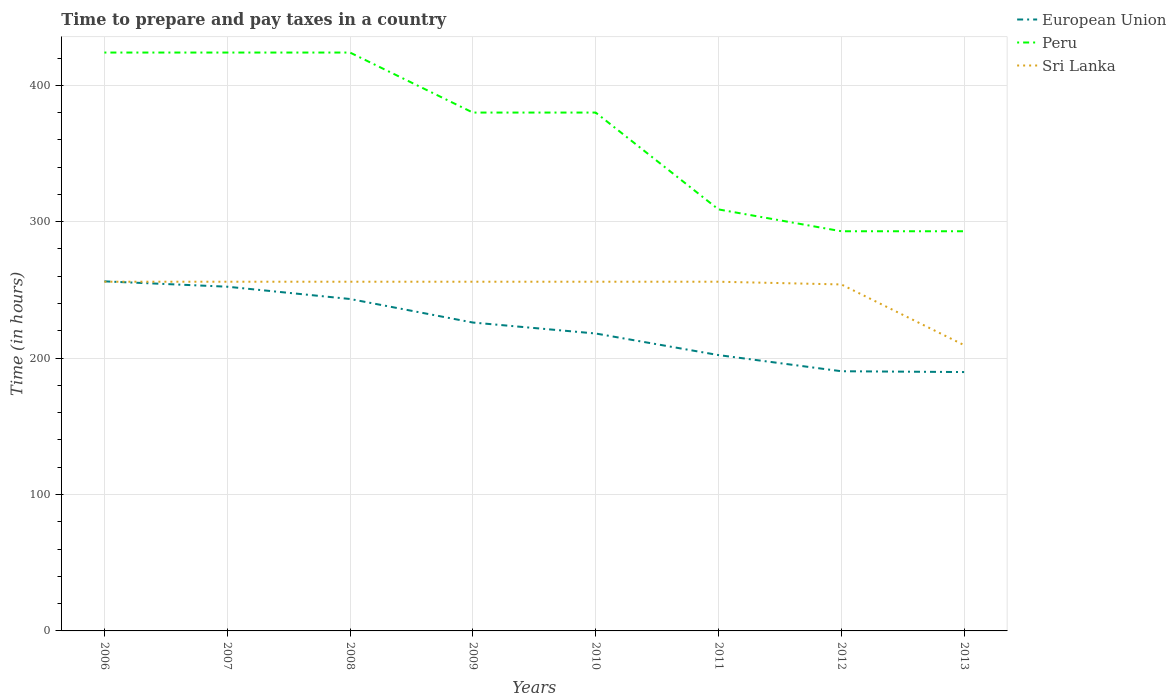How many different coloured lines are there?
Offer a very short reply. 3. Does the line corresponding to Sri Lanka intersect with the line corresponding to Peru?
Give a very brief answer. No. Across all years, what is the maximum number of hours required to prepare and pay taxes in Sri Lanka?
Ensure brevity in your answer.  209.5. What is the difference between the highest and the second highest number of hours required to prepare and pay taxes in Sri Lanka?
Offer a terse response. 46.5. What is the difference between the highest and the lowest number of hours required to prepare and pay taxes in Sri Lanka?
Ensure brevity in your answer.  7. Is the number of hours required to prepare and pay taxes in European Union strictly greater than the number of hours required to prepare and pay taxes in Peru over the years?
Offer a terse response. Yes. Does the graph contain any zero values?
Your answer should be compact. No. How many legend labels are there?
Ensure brevity in your answer.  3. How are the legend labels stacked?
Make the answer very short. Vertical. What is the title of the graph?
Offer a terse response. Time to prepare and pay taxes in a country. Does "Cabo Verde" appear as one of the legend labels in the graph?
Your response must be concise. No. What is the label or title of the Y-axis?
Provide a succinct answer. Time (in hours). What is the Time (in hours) of European Union in 2006?
Provide a succinct answer. 256.27. What is the Time (in hours) of Peru in 2006?
Your answer should be very brief. 424. What is the Time (in hours) of Sri Lanka in 2006?
Provide a succinct answer. 256. What is the Time (in hours) of European Union in 2007?
Keep it short and to the point. 252.35. What is the Time (in hours) of Peru in 2007?
Make the answer very short. 424. What is the Time (in hours) in Sri Lanka in 2007?
Ensure brevity in your answer.  256. What is the Time (in hours) of European Union in 2008?
Keep it short and to the point. 243.33. What is the Time (in hours) of Peru in 2008?
Provide a short and direct response. 424. What is the Time (in hours) of Sri Lanka in 2008?
Ensure brevity in your answer.  256. What is the Time (in hours) of European Union in 2009?
Give a very brief answer. 226.07. What is the Time (in hours) in Peru in 2009?
Provide a short and direct response. 380. What is the Time (in hours) of Sri Lanka in 2009?
Offer a very short reply. 256. What is the Time (in hours) of European Union in 2010?
Keep it short and to the point. 218.04. What is the Time (in hours) in Peru in 2010?
Provide a short and direct response. 380. What is the Time (in hours) in Sri Lanka in 2010?
Provide a succinct answer. 256. What is the Time (in hours) in European Union in 2011?
Provide a succinct answer. 202.21. What is the Time (in hours) in Peru in 2011?
Provide a short and direct response. 309. What is the Time (in hours) of Sri Lanka in 2011?
Keep it short and to the point. 256. What is the Time (in hours) of European Union in 2012?
Ensure brevity in your answer.  190.38. What is the Time (in hours) in Peru in 2012?
Your answer should be compact. 293. What is the Time (in hours) in Sri Lanka in 2012?
Provide a short and direct response. 254. What is the Time (in hours) in European Union in 2013?
Ensure brevity in your answer.  189.77. What is the Time (in hours) of Peru in 2013?
Provide a short and direct response. 293. What is the Time (in hours) in Sri Lanka in 2013?
Your response must be concise. 209.5. Across all years, what is the maximum Time (in hours) in European Union?
Keep it short and to the point. 256.27. Across all years, what is the maximum Time (in hours) in Peru?
Offer a terse response. 424. Across all years, what is the maximum Time (in hours) in Sri Lanka?
Your answer should be very brief. 256. Across all years, what is the minimum Time (in hours) in European Union?
Offer a very short reply. 189.77. Across all years, what is the minimum Time (in hours) of Peru?
Keep it short and to the point. 293. Across all years, what is the minimum Time (in hours) of Sri Lanka?
Ensure brevity in your answer.  209.5. What is the total Time (in hours) in European Union in the graph?
Provide a short and direct response. 1778.42. What is the total Time (in hours) in Peru in the graph?
Your answer should be very brief. 2927. What is the total Time (in hours) of Sri Lanka in the graph?
Offer a terse response. 1999.5. What is the difference between the Time (in hours) in European Union in 2006 and that in 2007?
Provide a succinct answer. 3.92. What is the difference between the Time (in hours) of Sri Lanka in 2006 and that in 2007?
Give a very brief answer. 0. What is the difference between the Time (in hours) in European Union in 2006 and that in 2008?
Keep it short and to the point. 12.94. What is the difference between the Time (in hours) of Peru in 2006 and that in 2008?
Your answer should be compact. 0. What is the difference between the Time (in hours) of European Union in 2006 and that in 2009?
Your response must be concise. 30.2. What is the difference between the Time (in hours) in European Union in 2006 and that in 2010?
Make the answer very short. 38.23. What is the difference between the Time (in hours) of Peru in 2006 and that in 2010?
Give a very brief answer. 44. What is the difference between the Time (in hours) of European Union in 2006 and that in 2011?
Your answer should be very brief. 54.05. What is the difference between the Time (in hours) in Peru in 2006 and that in 2011?
Your answer should be compact. 115. What is the difference between the Time (in hours) of Sri Lanka in 2006 and that in 2011?
Your response must be concise. 0. What is the difference between the Time (in hours) in European Union in 2006 and that in 2012?
Your answer should be compact. 65.89. What is the difference between the Time (in hours) of Peru in 2006 and that in 2012?
Offer a terse response. 131. What is the difference between the Time (in hours) in European Union in 2006 and that in 2013?
Ensure brevity in your answer.  66.5. What is the difference between the Time (in hours) in Peru in 2006 and that in 2013?
Your answer should be compact. 131. What is the difference between the Time (in hours) in Sri Lanka in 2006 and that in 2013?
Your answer should be compact. 46.5. What is the difference between the Time (in hours) in European Union in 2007 and that in 2008?
Make the answer very short. 9.01. What is the difference between the Time (in hours) of Peru in 2007 and that in 2008?
Your answer should be compact. 0. What is the difference between the Time (in hours) of European Union in 2007 and that in 2009?
Your answer should be very brief. 26.27. What is the difference between the Time (in hours) in European Union in 2007 and that in 2010?
Your response must be concise. 34.31. What is the difference between the Time (in hours) in Peru in 2007 and that in 2010?
Your answer should be compact. 44. What is the difference between the Time (in hours) of Sri Lanka in 2007 and that in 2010?
Keep it short and to the point. 0. What is the difference between the Time (in hours) of European Union in 2007 and that in 2011?
Ensure brevity in your answer.  50.13. What is the difference between the Time (in hours) in Peru in 2007 and that in 2011?
Offer a terse response. 115. What is the difference between the Time (in hours) in European Union in 2007 and that in 2012?
Offer a terse response. 61.97. What is the difference between the Time (in hours) of Peru in 2007 and that in 2012?
Your answer should be very brief. 131. What is the difference between the Time (in hours) of Sri Lanka in 2007 and that in 2012?
Keep it short and to the point. 2. What is the difference between the Time (in hours) in European Union in 2007 and that in 2013?
Provide a succinct answer. 62.58. What is the difference between the Time (in hours) of Peru in 2007 and that in 2013?
Make the answer very short. 131. What is the difference between the Time (in hours) in Sri Lanka in 2007 and that in 2013?
Your answer should be very brief. 46.5. What is the difference between the Time (in hours) in European Union in 2008 and that in 2009?
Provide a succinct answer. 17.26. What is the difference between the Time (in hours) in European Union in 2008 and that in 2010?
Give a very brief answer. 25.3. What is the difference between the Time (in hours) in Peru in 2008 and that in 2010?
Make the answer very short. 44. What is the difference between the Time (in hours) in European Union in 2008 and that in 2011?
Give a very brief answer. 41.12. What is the difference between the Time (in hours) in Peru in 2008 and that in 2011?
Provide a succinct answer. 115. What is the difference between the Time (in hours) in Sri Lanka in 2008 and that in 2011?
Give a very brief answer. 0. What is the difference between the Time (in hours) in European Union in 2008 and that in 2012?
Your answer should be compact. 52.96. What is the difference between the Time (in hours) in Peru in 2008 and that in 2012?
Offer a very short reply. 131. What is the difference between the Time (in hours) in Sri Lanka in 2008 and that in 2012?
Keep it short and to the point. 2. What is the difference between the Time (in hours) in European Union in 2008 and that in 2013?
Keep it short and to the point. 53.57. What is the difference between the Time (in hours) of Peru in 2008 and that in 2013?
Provide a succinct answer. 131. What is the difference between the Time (in hours) of Sri Lanka in 2008 and that in 2013?
Give a very brief answer. 46.5. What is the difference between the Time (in hours) of European Union in 2009 and that in 2010?
Keep it short and to the point. 8.04. What is the difference between the Time (in hours) of European Union in 2009 and that in 2011?
Your answer should be very brief. 23.86. What is the difference between the Time (in hours) in Peru in 2009 and that in 2011?
Your answer should be very brief. 71. What is the difference between the Time (in hours) of Sri Lanka in 2009 and that in 2011?
Ensure brevity in your answer.  0. What is the difference between the Time (in hours) in European Union in 2009 and that in 2012?
Ensure brevity in your answer.  35.7. What is the difference between the Time (in hours) of Peru in 2009 and that in 2012?
Provide a succinct answer. 87. What is the difference between the Time (in hours) in European Union in 2009 and that in 2013?
Provide a succinct answer. 36.31. What is the difference between the Time (in hours) in Peru in 2009 and that in 2013?
Provide a succinct answer. 87. What is the difference between the Time (in hours) of Sri Lanka in 2009 and that in 2013?
Your answer should be very brief. 46.5. What is the difference between the Time (in hours) of European Union in 2010 and that in 2011?
Offer a terse response. 15.82. What is the difference between the Time (in hours) of Peru in 2010 and that in 2011?
Ensure brevity in your answer.  71. What is the difference between the Time (in hours) in Sri Lanka in 2010 and that in 2011?
Your answer should be very brief. 0. What is the difference between the Time (in hours) of European Union in 2010 and that in 2012?
Ensure brevity in your answer.  27.66. What is the difference between the Time (in hours) of Peru in 2010 and that in 2012?
Make the answer very short. 87. What is the difference between the Time (in hours) in Sri Lanka in 2010 and that in 2012?
Ensure brevity in your answer.  2. What is the difference between the Time (in hours) in European Union in 2010 and that in 2013?
Provide a short and direct response. 28.27. What is the difference between the Time (in hours) of Peru in 2010 and that in 2013?
Make the answer very short. 87. What is the difference between the Time (in hours) of Sri Lanka in 2010 and that in 2013?
Offer a terse response. 46.5. What is the difference between the Time (in hours) of European Union in 2011 and that in 2012?
Ensure brevity in your answer.  11.84. What is the difference between the Time (in hours) in European Union in 2011 and that in 2013?
Ensure brevity in your answer.  12.45. What is the difference between the Time (in hours) in Peru in 2011 and that in 2013?
Provide a succinct answer. 16. What is the difference between the Time (in hours) of Sri Lanka in 2011 and that in 2013?
Offer a terse response. 46.5. What is the difference between the Time (in hours) in European Union in 2012 and that in 2013?
Your answer should be compact. 0.61. What is the difference between the Time (in hours) of Peru in 2012 and that in 2013?
Give a very brief answer. 0. What is the difference between the Time (in hours) in Sri Lanka in 2012 and that in 2013?
Your answer should be very brief. 44.5. What is the difference between the Time (in hours) in European Union in 2006 and the Time (in hours) in Peru in 2007?
Offer a very short reply. -167.73. What is the difference between the Time (in hours) in European Union in 2006 and the Time (in hours) in Sri Lanka in 2007?
Provide a short and direct response. 0.27. What is the difference between the Time (in hours) in Peru in 2006 and the Time (in hours) in Sri Lanka in 2007?
Ensure brevity in your answer.  168. What is the difference between the Time (in hours) of European Union in 2006 and the Time (in hours) of Peru in 2008?
Give a very brief answer. -167.73. What is the difference between the Time (in hours) in European Union in 2006 and the Time (in hours) in Sri Lanka in 2008?
Your answer should be compact. 0.27. What is the difference between the Time (in hours) in Peru in 2006 and the Time (in hours) in Sri Lanka in 2008?
Offer a very short reply. 168. What is the difference between the Time (in hours) of European Union in 2006 and the Time (in hours) of Peru in 2009?
Make the answer very short. -123.73. What is the difference between the Time (in hours) of European Union in 2006 and the Time (in hours) of Sri Lanka in 2009?
Offer a very short reply. 0.27. What is the difference between the Time (in hours) of Peru in 2006 and the Time (in hours) of Sri Lanka in 2009?
Provide a short and direct response. 168. What is the difference between the Time (in hours) in European Union in 2006 and the Time (in hours) in Peru in 2010?
Your answer should be compact. -123.73. What is the difference between the Time (in hours) of European Union in 2006 and the Time (in hours) of Sri Lanka in 2010?
Ensure brevity in your answer.  0.27. What is the difference between the Time (in hours) of Peru in 2006 and the Time (in hours) of Sri Lanka in 2010?
Keep it short and to the point. 168. What is the difference between the Time (in hours) in European Union in 2006 and the Time (in hours) in Peru in 2011?
Provide a short and direct response. -52.73. What is the difference between the Time (in hours) in European Union in 2006 and the Time (in hours) in Sri Lanka in 2011?
Ensure brevity in your answer.  0.27. What is the difference between the Time (in hours) of Peru in 2006 and the Time (in hours) of Sri Lanka in 2011?
Your response must be concise. 168. What is the difference between the Time (in hours) of European Union in 2006 and the Time (in hours) of Peru in 2012?
Make the answer very short. -36.73. What is the difference between the Time (in hours) of European Union in 2006 and the Time (in hours) of Sri Lanka in 2012?
Provide a succinct answer. 2.27. What is the difference between the Time (in hours) of Peru in 2006 and the Time (in hours) of Sri Lanka in 2012?
Make the answer very short. 170. What is the difference between the Time (in hours) of European Union in 2006 and the Time (in hours) of Peru in 2013?
Your answer should be very brief. -36.73. What is the difference between the Time (in hours) of European Union in 2006 and the Time (in hours) of Sri Lanka in 2013?
Offer a terse response. 46.77. What is the difference between the Time (in hours) in Peru in 2006 and the Time (in hours) in Sri Lanka in 2013?
Your answer should be very brief. 214.5. What is the difference between the Time (in hours) in European Union in 2007 and the Time (in hours) in Peru in 2008?
Keep it short and to the point. -171.65. What is the difference between the Time (in hours) in European Union in 2007 and the Time (in hours) in Sri Lanka in 2008?
Your response must be concise. -3.65. What is the difference between the Time (in hours) of Peru in 2007 and the Time (in hours) of Sri Lanka in 2008?
Your answer should be very brief. 168. What is the difference between the Time (in hours) in European Union in 2007 and the Time (in hours) in Peru in 2009?
Ensure brevity in your answer.  -127.65. What is the difference between the Time (in hours) in European Union in 2007 and the Time (in hours) in Sri Lanka in 2009?
Keep it short and to the point. -3.65. What is the difference between the Time (in hours) in Peru in 2007 and the Time (in hours) in Sri Lanka in 2009?
Your response must be concise. 168. What is the difference between the Time (in hours) of European Union in 2007 and the Time (in hours) of Peru in 2010?
Make the answer very short. -127.65. What is the difference between the Time (in hours) in European Union in 2007 and the Time (in hours) in Sri Lanka in 2010?
Make the answer very short. -3.65. What is the difference between the Time (in hours) in Peru in 2007 and the Time (in hours) in Sri Lanka in 2010?
Make the answer very short. 168. What is the difference between the Time (in hours) of European Union in 2007 and the Time (in hours) of Peru in 2011?
Provide a short and direct response. -56.65. What is the difference between the Time (in hours) in European Union in 2007 and the Time (in hours) in Sri Lanka in 2011?
Offer a very short reply. -3.65. What is the difference between the Time (in hours) in Peru in 2007 and the Time (in hours) in Sri Lanka in 2011?
Make the answer very short. 168. What is the difference between the Time (in hours) in European Union in 2007 and the Time (in hours) in Peru in 2012?
Offer a very short reply. -40.65. What is the difference between the Time (in hours) in European Union in 2007 and the Time (in hours) in Sri Lanka in 2012?
Keep it short and to the point. -1.65. What is the difference between the Time (in hours) of Peru in 2007 and the Time (in hours) of Sri Lanka in 2012?
Ensure brevity in your answer.  170. What is the difference between the Time (in hours) of European Union in 2007 and the Time (in hours) of Peru in 2013?
Your answer should be compact. -40.65. What is the difference between the Time (in hours) of European Union in 2007 and the Time (in hours) of Sri Lanka in 2013?
Offer a terse response. 42.85. What is the difference between the Time (in hours) in Peru in 2007 and the Time (in hours) in Sri Lanka in 2013?
Your answer should be compact. 214.5. What is the difference between the Time (in hours) of European Union in 2008 and the Time (in hours) of Peru in 2009?
Make the answer very short. -136.67. What is the difference between the Time (in hours) in European Union in 2008 and the Time (in hours) in Sri Lanka in 2009?
Your response must be concise. -12.67. What is the difference between the Time (in hours) in Peru in 2008 and the Time (in hours) in Sri Lanka in 2009?
Make the answer very short. 168. What is the difference between the Time (in hours) in European Union in 2008 and the Time (in hours) in Peru in 2010?
Keep it short and to the point. -136.67. What is the difference between the Time (in hours) of European Union in 2008 and the Time (in hours) of Sri Lanka in 2010?
Offer a terse response. -12.67. What is the difference between the Time (in hours) of Peru in 2008 and the Time (in hours) of Sri Lanka in 2010?
Give a very brief answer. 168. What is the difference between the Time (in hours) of European Union in 2008 and the Time (in hours) of Peru in 2011?
Offer a very short reply. -65.67. What is the difference between the Time (in hours) of European Union in 2008 and the Time (in hours) of Sri Lanka in 2011?
Offer a terse response. -12.67. What is the difference between the Time (in hours) of Peru in 2008 and the Time (in hours) of Sri Lanka in 2011?
Ensure brevity in your answer.  168. What is the difference between the Time (in hours) in European Union in 2008 and the Time (in hours) in Peru in 2012?
Your response must be concise. -49.67. What is the difference between the Time (in hours) of European Union in 2008 and the Time (in hours) of Sri Lanka in 2012?
Provide a short and direct response. -10.67. What is the difference between the Time (in hours) in Peru in 2008 and the Time (in hours) in Sri Lanka in 2012?
Ensure brevity in your answer.  170. What is the difference between the Time (in hours) in European Union in 2008 and the Time (in hours) in Peru in 2013?
Provide a succinct answer. -49.67. What is the difference between the Time (in hours) in European Union in 2008 and the Time (in hours) in Sri Lanka in 2013?
Your answer should be very brief. 33.83. What is the difference between the Time (in hours) of Peru in 2008 and the Time (in hours) of Sri Lanka in 2013?
Make the answer very short. 214.5. What is the difference between the Time (in hours) of European Union in 2009 and the Time (in hours) of Peru in 2010?
Ensure brevity in your answer.  -153.93. What is the difference between the Time (in hours) in European Union in 2009 and the Time (in hours) in Sri Lanka in 2010?
Offer a terse response. -29.93. What is the difference between the Time (in hours) of Peru in 2009 and the Time (in hours) of Sri Lanka in 2010?
Keep it short and to the point. 124. What is the difference between the Time (in hours) of European Union in 2009 and the Time (in hours) of Peru in 2011?
Offer a terse response. -82.93. What is the difference between the Time (in hours) of European Union in 2009 and the Time (in hours) of Sri Lanka in 2011?
Provide a succinct answer. -29.93. What is the difference between the Time (in hours) of Peru in 2009 and the Time (in hours) of Sri Lanka in 2011?
Make the answer very short. 124. What is the difference between the Time (in hours) in European Union in 2009 and the Time (in hours) in Peru in 2012?
Ensure brevity in your answer.  -66.93. What is the difference between the Time (in hours) of European Union in 2009 and the Time (in hours) of Sri Lanka in 2012?
Give a very brief answer. -27.93. What is the difference between the Time (in hours) in Peru in 2009 and the Time (in hours) in Sri Lanka in 2012?
Your answer should be compact. 126. What is the difference between the Time (in hours) in European Union in 2009 and the Time (in hours) in Peru in 2013?
Make the answer very short. -66.93. What is the difference between the Time (in hours) in European Union in 2009 and the Time (in hours) in Sri Lanka in 2013?
Your response must be concise. 16.57. What is the difference between the Time (in hours) in Peru in 2009 and the Time (in hours) in Sri Lanka in 2013?
Your response must be concise. 170.5. What is the difference between the Time (in hours) in European Union in 2010 and the Time (in hours) in Peru in 2011?
Your answer should be compact. -90.96. What is the difference between the Time (in hours) in European Union in 2010 and the Time (in hours) in Sri Lanka in 2011?
Your answer should be very brief. -37.96. What is the difference between the Time (in hours) in Peru in 2010 and the Time (in hours) in Sri Lanka in 2011?
Keep it short and to the point. 124. What is the difference between the Time (in hours) of European Union in 2010 and the Time (in hours) of Peru in 2012?
Provide a succinct answer. -74.96. What is the difference between the Time (in hours) in European Union in 2010 and the Time (in hours) in Sri Lanka in 2012?
Give a very brief answer. -35.96. What is the difference between the Time (in hours) of Peru in 2010 and the Time (in hours) of Sri Lanka in 2012?
Provide a short and direct response. 126. What is the difference between the Time (in hours) of European Union in 2010 and the Time (in hours) of Peru in 2013?
Provide a short and direct response. -74.96. What is the difference between the Time (in hours) in European Union in 2010 and the Time (in hours) in Sri Lanka in 2013?
Your answer should be very brief. 8.54. What is the difference between the Time (in hours) of Peru in 2010 and the Time (in hours) of Sri Lanka in 2013?
Keep it short and to the point. 170.5. What is the difference between the Time (in hours) of European Union in 2011 and the Time (in hours) of Peru in 2012?
Make the answer very short. -90.79. What is the difference between the Time (in hours) in European Union in 2011 and the Time (in hours) in Sri Lanka in 2012?
Offer a terse response. -51.79. What is the difference between the Time (in hours) in Peru in 2011 and the Time (in hours) in Sri Lanka in 2012?
Give a very brief answer. 55. What is the difference between the Time (in hours) of European Union in 2011 and the Time (in hours) of Peru in 2013?
Offer a terse response. -90.79. What is the difference between the Time (in hours) of European Union in 2011 and the Time (in hours) of Sri Lanka in 2013?
Offer a terse response. -7.29. What is the difference between the Time (in hours) of Peru in 2011 and the Time (in hours) of Sri Lanka in 2013?
Ensure brevity in your answer.  99.5. What is the difference between the Time (in hours) in European Union in 2012 and the Time (in hours) in Peru in 2013?
Your response must be concise. -102.62. What is the difference between the Time (in hours) of European Union in 2012 and the Time (in hours) of Sri Lanka in 2013?
Your answer should be compact. -19.12. What is the difference between the Time (in hours) of Peru in 2012 and the Time (in hours) of Sri Lanka in 2013?
Provide a short and direct response. 83.5. What is the average Time (in hours) in European Union per year?
Provide a short and direct response. 222.3. What is the average Time (in hours) in Peru per year?
Make the answer very short. 365.88. What is the average Time (in hours) in Sri Lanka per year?
Offer a terse response. 249.94. In the year 2006, what is the difference between the Time (in hours) of European Union and Time (in hours) of Peru?
Offer a terse response. -167.73. In the year 2006, what is the difference between the Time (in hours) in European Union and Time (in hours) in Sri Lanka?
Your response must be concise. 0.27. In the year 2006, what is the difference between the Time (in hours) of Peru and Time (in hours) of Sri Lanka?
Make the answer very short. 168. In the year 2007, what is the difference between the Time (in hours) in European Union and Time (in hours) in Peru?
Keep it short and to the point. -171.65. In the year 2007, what is the difference between the Time (in hours) of European Union and Time (in hours) of Sri Lanka?
Your response must be concise. -3.65. In the year 2007, what is the difference between the Time (in hours) of Peru and Time (in hours) of Sri Lanka?
Provide a succinct answer. 168. In the year 2008, what is the difference between the Time (in hours) of European Union and Time (in hours) of Peru?
Provide a succinct answer. -180.67. In the year 2008, what is the difference between the Time (in hours) in European Union and Time (in hours) in Sri Lanka?
Your answer should be compact. -12.67. In the year 2008, what is the difference between the Time (in hours) in Peru and Time (in hours) in Sri Lanka?
Offer a very short reply. 168. In the year 2009, what is the difference between the Time (in hours) in European Union and Time (in hours) in Peru?
Your answer should be very brief. -153.93. In the year 2009, what is the difference between the Time (in hours) in European Union and Time (in hours) in Sri Lanka?
Offer a terse response. -29.93. In the year 2009, what is the difference between the Time (in hours) in Peru and Time (in hours) in Sri Lanka?
Offer a terse response. 124. In the year 2010, what is the difference between the Time (in hours) of European Union and Time (in hours) of Peru?
Your answer should be compact. -161.96. In the year 2010, what is the difference between the Time (in hours) in European Union and Time (in hours) in Sri Lanka?
Your answer should be very brief. -37.96. In the year 2010, what is the difference between the Time (in hours) in Peru and Time (in hours) in Sri Lanka?
Ensure brevity in your answer.  124. In the year 2011, what is the difference between the Time (in hours) in European Union and Time (in hours) in Peru?
Offer a very short reply. -106.79. In the year 2011, what is the difference between the Time (in hours) in European Union and Time (in hours) in Sri Lanka?
Make the answer very short. -53.79. In the year 2012, what is the difference between the Time (in hours) of European Union and Time (in hours) of Peru?
Give a very brief answer. -102.62. In the year 2012, what is the difference between the Time (in hours) of European Union and Time (in hours) of Sri Lanka?
Your response must be concise. -63.62. In the year 2013, what is the difference between the Time (in hours) of European Union and Time (in hours) of Peru?
Provide a succinct answer. -103.23. In the year 2013, what is the difference between the Time (in hours) in European Union and Time (in hours) in Sri Lanka?
Your response must be concise. -19.73. In the year 2013, what is the difference between the Time (in hours) of Peru and Time (in hours) of Sri Lanka?
Keep it short and to the point. 83.5. What is the ratio of the Time (in hours) of European Union in 2006 to that in 2007?
Your response must be concise. 1.02. What is the ratio of the Time (in hours) in Sri Lanka in 2006 to that in 2007?
Keep it short and to the point. 1. What is the ratio of the Time (in hours) of European Union in 2006 to that in 2008?
Provide a short and direct response. 1.05. What is the ratio of the Time (in hours) in Peru in 2006 to that in 2008?
Give a very brief answer. 1. What is the ratio of the Time (in hours) of European Union in 2006 to that in 2009?
Offer a terse response. 1.13. What is the ratio of the Time (in hours) in Peru in 2006 to that in 2009?
Make the answer very short. 1.12. What is the ratio of the Time (in hours) of European Union in 2006 to that in 2010?
Make the answer very short. 1.18. What is the ratio of the Time (in hours) of Peru in 2006 to that in 2010?
Make the answer very short. 1.12. What is the ratio of the Time (in hours) of European Union in 2006 to that in 2011?
Your answer should be compact. 1.27. What is the ratio of the Time (in hours) of Peru in 2006 to that in 2011?
Your answer should be very brief. 1.37. What is the ratio of the Time (in hours) of Sri Lanka in 2006 to that in 2011?
Keep it short and to the point. 1. What is the ratio of the Time (in hours) of European Union in 2006 to that in 2012?
Provide a short and direct response. 1.35. What is the ratio of the Time (in hours) in Peru in 2006 to that in 2012?
Your response must be concise. 1.45. What is the ratio of the Time (in hours) of Sri Lanka in 2006 to that in 2012?
Your answer should be compact. 1.01. What is the ratio of the Time (in hours) in European Union in 2006 to that in 2013?
Your answer should be compact. 1.35. What is the ratio of the Time (in hours) in Peru in 2006 to that in 2013?
Keep it short and to the point. 1.45. What is the ratio of the Time (in hours) of Sri Lanka in 2006 to that in 2013?
Provide a short and direct response. 1.22. What is the ratio of the Time (in hours) in Peru in 2007 to that in 2008?
Provide a succinct answer. 1. What is the ratio of the Time (in hours) in Sri Lanka in 2007 to that in 2008?
Ensure brevity in your answer.  1. What is the ratio of the Time (in hours) in European Union in 2007 to that in 2009?
Offer a very short reply. 1.12. What is the ratio of the Time (in hours) in Peru in 2007 to that in 2009?
Make the answer very short. 1.12. What is the ratio of the Time (in hours) of European Union in 2007 to that in 2010?
Your answer should be very brief. 1.16. What is the ratio of the Time (in hours) of Peru in 2007 to that in 2010?
Provide a succinct answer. 1.12. What is the ratio of the Time (in hours) in European Union in 2007 to that in 2011?
Make the answer very short. 1.25. What is the ratio of the Time (in hours) of Peru in 2007 to that in 2011?
Offer a very short reply. 1.37. What is the ratio of the Time (in hours) of Sri Lanka in 2007 to that in 2011?
Provide a short and direct response. 1. What is the ratio of the Time (in hours) of European Union in 2007 to that in 2012?
Provide a succinct answer. 1.33. What is the ratio of the Time (in hours) of Peru in 2007 to that in 2012?
Offer a terse response. 1.45. What is the ratio of the Time (in hours) of Sri Lanka in 2007 to that in 2012?
Offer a very short reply. 1.01. What is the ratio of the Time (in hours) in European Union in 2007 to that in 2013?
Provide a short and direct response. 1.33. What is the ratio of the Time (in hours) of Peru in 2007 to that in 2013?
Your answer should be compact. 1.45. What is the ratio of the Time (in hours) of Sri Lanka in 2007 to that in 2013?
Your response must be concise. 1.22. What is the ratio of the Time (in hours) in European Union in 2008 to that in 2009?
Ensure brevity in your answer.  1.08. What is the ratio of the Time (in hours) in Peru in 2008 to that in 2009?
Provide a short and direct response. 1.12. What is the ratio of the Time (in hours) of European Union in 2008 to that in 2010?
Your response must be concise. 1.12. What is the ratio of the Time (in hours) in Peru in 2008 to that in 2010?
Provide a succinct answer. 1.12. What is the ratio of the Time (in hours) in Sri Lanka in 2008 to that in 2010?
Your answer should be very brief. 1. What is the ratio of the Time (in hours) of European Union in 2008 to that in 2011?
Offer a very short reply. 1.2. What is the ratio of the Time (in hours) of Peru in 2008 to that in 2011?
Ensure brevity in your answer.  1.37. What is the ratio of the Time (in hours) in European Union in 2008 to that in 2012?
Keep it short and to the point. 1.28. What is the ratio of the Time (in hours) of Peru in 2008 to that in 2012?
Offer a very short reply. 1.45. What is the ratio of the Time (in hours) of Sri Lanka in 2008 to that in 2012?
Your answer should be very brief. 1.01. What is the ratio of the Time (in hours) in European Union in 2008 to that in 2013?
Make the answer very short. 1.28. What is the ratio of the Time (in hours) of Peru in 2008 to that in 2013?
Ensure brevity in your answer.  1.45. What is the ratio of the Time (in hours) in Sri Lanka in 2008 to that in 2013?
Offer a terse response. 1.22. What is the ratio of the Time (in hours) in European Union in 2009 to that in 2010?
Your response must be concise. 1.04. What is the ratio of the Time (in hours) of Peru in 2009 to that in 2010?
Keep it short and to the point. 1. What is the ratio of the Time (in hours) of European Union in 2009 to that in 2011?
Offer a terse response. 1.12. What is the ratio of the Time (in hours) in Peru in 2009 to that in 2011?
Keep it short and to the point. 1.23. What is the ratio of the Time (in hours) of Sri Lanka in 2009 to that in 2011?
Provide a short and direct response. 1. What is the ratio of the Time (in hours) of European Union in 2009 to that in 2012?
Your answer should be very brief. 1.19. What is the ratio of the Time (in hours) of Peru in 2009 to that in 2012?
Offer a very short reply. 1.3. What is the ratio of the Time (in hours) in Sri Lanka in 2009 to that in 2012?
Give a very brief answer. 1.01. What is the ratio of the Time (in hours) of European Union in 2009 to that in 2013?
Provide a succinct answer. 1.19. What is the ratio of the Time (in hours) of Peru in 2009 to that in 2013?
Offer a terse response. 1.3. What is the ratio of the Time (in hours) in Sri Lanka in 2009 to that in 2013?
Offer a very short reply. 1.22. What is the ratio of the Time (in hours) of European Union in 2010 to that in 2011?
Keep it short and to the point. 1.08. What is the ratio of the Time (in hours) in Peru in 2010 to that in 2011?
Give a very brief answer. 1.23. What is the ratio of the Time (in hours) of Sri Lanka in 2010 to that in 2011?
Offer a very short reply. 1. What is the ratio of the Time (in hours) of European Union in 2010 to that in 2012?
Provide a short and direct response. 1.15. What is the ratio of the Time (in hours) in Peru in 2010 to that in 2012?
Ensure brevity in your answer.  1.3. What is the ratio of the Time (in hours) of Sri Lanka in 2010 to that in 2012?
Make the answer very short. 1.01. What is the ratio of the Time (in hours) of European Union in 2010 to that in 2013?
Keep it short and to the point. 1.15. What is the ratio of the Time (in hours) in Peru in 2010 to that in 2013?
Provide a succinct answer. 1.3. What is the ratio of the Time (in hours) of Sri Lanka in 2010 to that in 2013?
Keep it short and to the point. 1.22. What is the ratio of the Time (in hours) in European Union in 2011 to that in 2012?
Your response must be concise. 1.06. What is the ratio of the Time (in hours) of Peru in 2011 to that in 2012?
Provide a succinct answer. 1.05. What is the ratio of the Time (in hours) of Sri Lanka in 2011 to that in 2012?
Give a very brief answer. 1.01. What is the ratio of the Time (in hours) of European Union in 2011 to that in 2013?
Your answer should be compact. 1.07. What is the ratio of the Time (in hours) in Peru in 2011 to that in 2013?
Your answer should be very brief. 1.05. What is the ratio of the Time (in hours) in Sri Lanka in 2011 to that in 2013?
Your answer should be very brief. 1.22. What is the ratio of the Time (in hours) of European Union in 2012 to that in 2013?
Give a very brief answer. 1. What is the ratio of the Time (in hours) of Peru in 2012 to that in 2013?
Your answer should be very brief. 1. What is the ratio of the Time (in hours) in Sri Lanka in 2012 to that in 2013?
Give a very brief answer. 1.21. What is the difference between the highest and the second highest Time (in hours) of European Union?
Offer a very short reply. 3.92. What is the difference between the highest and the lowest Time (in hours) in European Union?
Offer a terse response. 66.5. What is the difference between the highest and the lowest Time (in hours) in Peru?
Give a very brief answer. 131. What is the difference between the highest and the lowest Time (in hours) of Sri Lanka?
Keep it short and to the point. 46.5. 